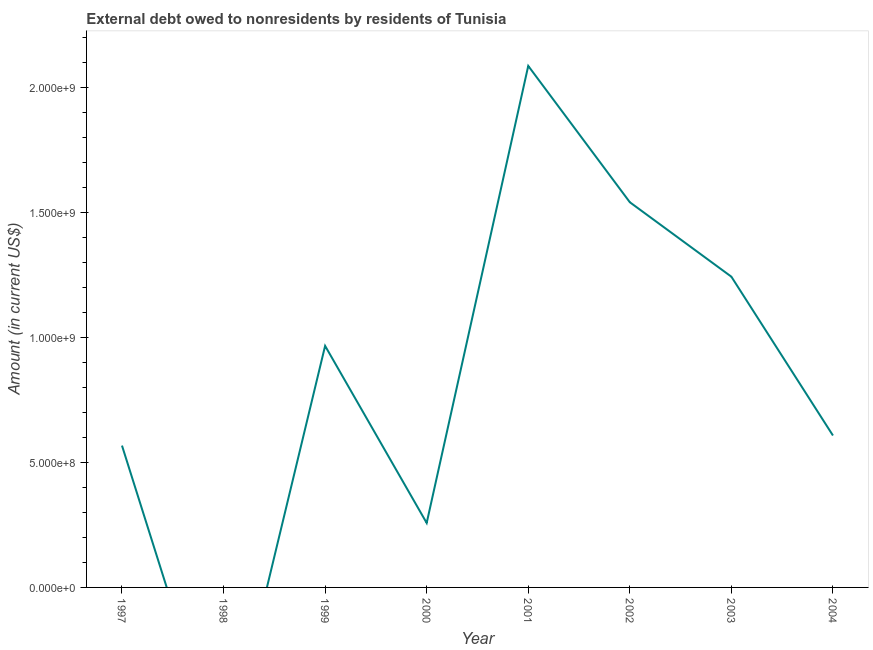What is the debt in 2002?
Provide a succinct answer. 1.54e+09. Across all years, what is the maximum debt?
Give a very brief answer. 2.09e+09. Across all years, what is the minimum debt?
Ensure brevity in your answer.  0. What is the sum of the debt?
Your answer should be compact. 7.27e+09. What is the difference between the debt in 2000 and 2001?
Provide a short and direct response. -1.83e+09. What is the average debt per year?
Offer a terse response. 9.09e+08. What is the median debt?
Offer a very short reply. 7.87e+08. In how many years, is the debt greater than 400000000 US$?
Your response must be concise. 6. What is the ratio of the debt in 2000 to that in 2003?
Offer a terse response. 0.21. Is the difference between the debt in 2001 and 2003 greater than the difference between any two years?
Provide a succinct answer. No. What is the difference between the highest and the second highest debt?
Keep it short and to the point. 5.45e+08. What is the difference between the highest and the lowest debt?
Offer a terse response. 2.09e+09. Does the debt monotonically increase over the years?
Keep it short and to the point. No. How many years are there in the graph?
Provide a short and direct response. 8. What is the difference between two consecutive major ticks on the Y-axis?
Your answer should be compact. 5.00e+08. Are the values on the major ticks of Y-axis written in scientific E-notation?
Give a very brief answer. Yes. Does the graph contain any zero values?
Provide a short and direct response. Yes. Does the graph contain grids?
Give a very brief answer. No. What is the title of the graph?
Give a very brief answer. External debt owed to nonresidents by residents of Tunisia. What is the label or title of the X-axis?
Offer a very short reply. Year. What is the label or title of the Y-axis?
Make the answer very short. Amount (in current US$). What is the Amount (in current US$) of 1997?
Give a very brief answer. 5.68e+08. What is the Amount (in current US$) in 1999?
Provide a short and direct response. 9.67e+08. What is the Amount (in current US$) of 2000?
Offer a very short reply. 2.58e+08. What is the Amount (in current US$) of 2001?
Keep it short and to the point. 2.09e+09. What is the Amount (in current US$) in 2002?
Make the answer very short. 1.54e+09. What is the Amount (in current US$) of 2003?
Your response must be concise. 1.24e+09. What is the Amount (in current US$) in 2004?
Offer a very short reply. 6.08e+08. What is the difference between the Amount (in current US$) in 1997 and 1999?
Make the answer very short. -3.99e+08. What is the difference between the Amount (in current US$) in 1997 and 2000?
Ensure brevity in your answer.  3.10e+08. What is the difference between the Amount (in current US$) in 1997 and 2001?
Give a very brief answer. -1.52e+09. What is the difference between the Amount (in current US$) in 1997 and 2002?
Offer a terse response. -9.74e+08. What is the difference between the Amount (in current US$) in 1997 and 2003?
Make the answer very short. -6.76e+08. What is the difference between the Amount (in current US$) in 1997 and 2004?
Ensure brevity in your answer.  -4.03e+07. What is the difference between the Amount (in current US$) in 1999 and 2000?
Keep it short and to the point. 7.09e+08. What is the difference between the Amount (in current US$) in 1999 and 2001?
Ensure brevity in your answer.  -1.12e+09. What is the difference between the Amount (in current US$) in 1999 and 2002?
Your response must be concise. -5.75e+08. What is the difference between the Amount (in current US$) in 1999 and 2003?
Your answer should be compact. -2.77e+08. What is the difference between the Amount (in current US$) in 1999 and 2004?
Provide a short and direct response. 3.59e+08. What is the difference between the Amount (in current US$) in 2000 and 2001?
Your answer should be very brief. -1.83e+09. What is the difference between the Amount (in current US$) in 2000 and 2002?
Your response must be concise. -1.28e+09. What is the difference between the Amount (in current US$) in 2000 and 2003?
Keep it short and to the point. -9.85e+08. What is the difference between the Amount (in current US$) in 2000 and 2004?
Offer a very short reply. -3.50e+08. What is the difference between the Amount (in current US$) in 2001 and 2002?
Your answer should be very brief. 5.45e+08. What is the difference between the Amount (in current US$) in 2001 and 2003?
Give a very brief answer. 8.43e+08. What is the difference between the Amount (in current US$) in 2001 and 2004?
Provide a short and direct response. 1.48e+09. What is the difference between the Amount (in current US$) in 2002 and 2003?
Provide a succinct answer. 2.98e+08. What is the difference between the Amount (in current US$) in 2002 and 2004?
Your answer should be very brief. 9.33e+08. What is the difference between the Amount (in current US$) in 2003 and 2004?
Your answer should be very brief. 6.35e+08. What is the ratio of the Amount (in current US$) in 1997 to that in 1999?
Make the answer very short. 0.59. What is the ratio of the Amount (in current US$) in 1997 to that in 2001?
Offer a very short reply. 0.27. What is the ratio of the Amount (in current US$) in 1997 to that in 2002?
Provide a succinct answer. 0.37. What is the ratio of the Amount (in current US$) in 1997 to that in 2003?
Your response must be concise. 0.46. What is the ratio of the Amount (in current US$) in 1997 to that in 2004?
Provide a short and direct response. 0.93. What is the ratio of the Amount (in current US$) in 1999 to that in 2000?
Your response must be concise. 3.75. What is the ratio of the Amount (in current US$) in 1999 to that in 2001?
Provide a succinct answer. 0.46. What is the ratio of the Amount (in current US$) in 1999 to that in 2002?
Your answer should be very brief. 0.63. What is the ratio of the Amount (in current US$) in 1999 to that in 2003?
Ensure brevity in your answer.  0.78. What is the ratio of the Amount (in current US$) in 1999 to that in 2004?
Offer a very short reply. 1.59. What is the ratio of the Amount (in current US$) in 2000 to that in 2001?
Offer a very short reply. 0.12. What is the ratio of the Amount (in current US$) in 2000 to that in 2002?
Your response must be concise. 0.17. What is the ratio of the Amount (in current US$) in 2000 to that in 2003?
Give a very brief answer. 0.21. What is the ratio of the Amount (in current US$) in 2000 to that in 2004?
Offer a terse response. 0.42. What is the ratio of the Amount (in current US$) in 2001 to that in 2002?
Give a very brief answer. 1.35. What is the ratio of the Amount (in current US$) in 2001 to that in 2003?
Your answer should be very brief. 1.68. What is the ratio of the Amount (in current US$) in 2001 to that in 2004?
Make the answer very short. 3.43. What is the ratio of the Amount (in current US$) in 2002 to that in 2003?
Offer a terse response. 1.24. What is the ratio of the Amount (in current US$) in 2002 to that in 2004?
Keep it short and to the point. 2.54. What is the ratio of the Amount (in current US$) in 2003 to that in 2004?
Ensure brevity in your answer.  2.04. 